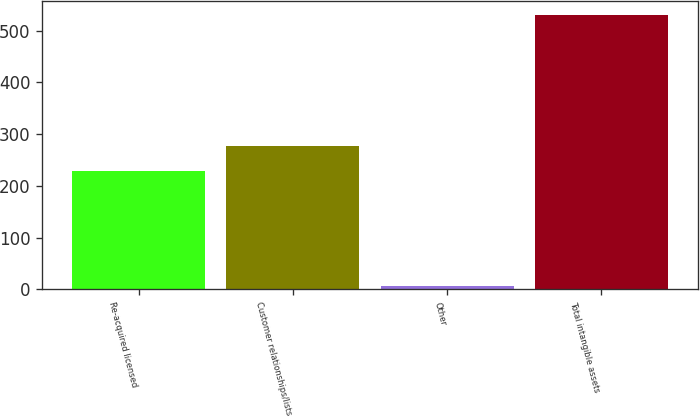Convert chart to OTSL. <chart><loc_0><loc_0><loc_500><loc_500><bar_chart><fcel>Re-acquired licensed<fcel>Customer relationships/lists<fcel>Other<fcel>Total intangible assets<nl><fcel>229.4<fcel>277.69<fcel>7.4<fcel>529.79<nl></chart> 